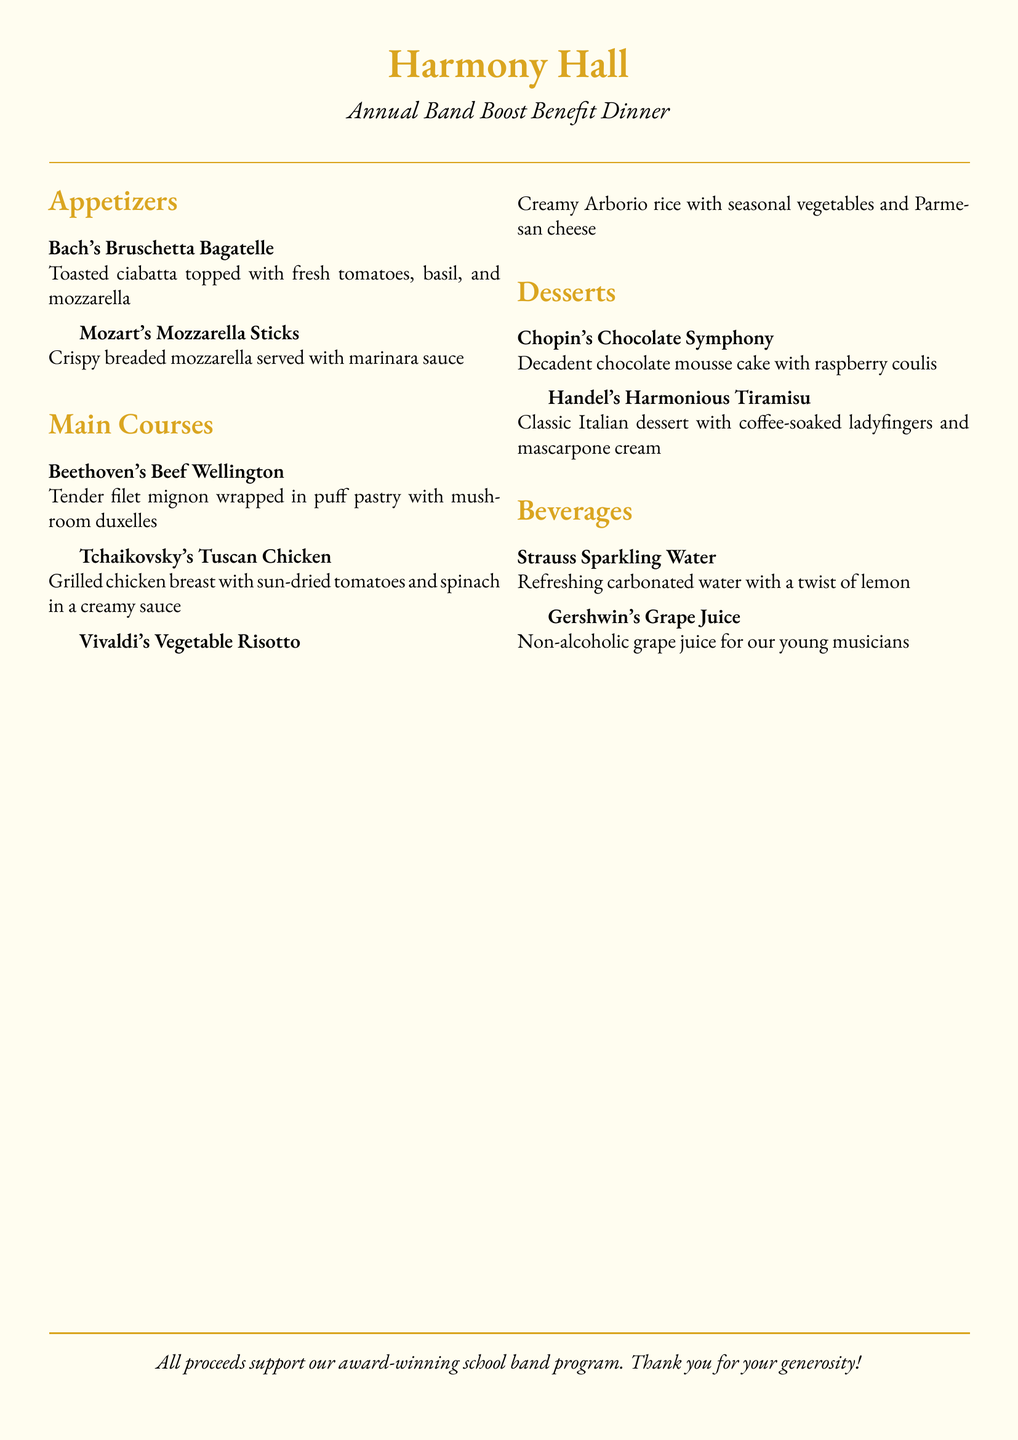What is the name of the dinner? The name of the dinner, as presented in the document, is "Annual Band Boost Benefit Dinner."
Answer: Annual Band Boost Benefit Dinner What dish is named after Vivaldi? The dish named after Vivaldi is "Vivaldi's Vegetable Risotto."
Answer: Vivaldi's Vegetable Risotto How many appetizers are listed on the menu? The number of appetizers listed is two: Bach's Bruschetta Bagatelle and Mozart's Mozzarella Sticks.
Answer: 2 What is included in Tchaikovsky's Tuscan Chicken? Tchaikovsky's Tuscan Chicken includes grilled chicken breast with sun-dried tomatoes and spinach in a creamy sauce.
Answer: Grilled chicken breast with sun-dried tomatoes and spinach in a creamy sauce What type of dessert is Chopin's offering? Chopin's offering is a decadent chocolate mousse cake with raspberry coulis.
Answer: Chocolate mousse cake with raspberry coulis Which beverage is non-alcoholic? The beverage that is non-alcoholic, as mentioned in the menu, is Gershwin's Grape Juice.
Answer: Gershwin's Grape Juice What color is the background of the menu? The background color of the menu is described as "creamback."
Answer: creamback What does the menu say about the proceeds? The menu states that all proceeds support the award-winning school band program.
Answer: All proceeds support our award-winning school band program 